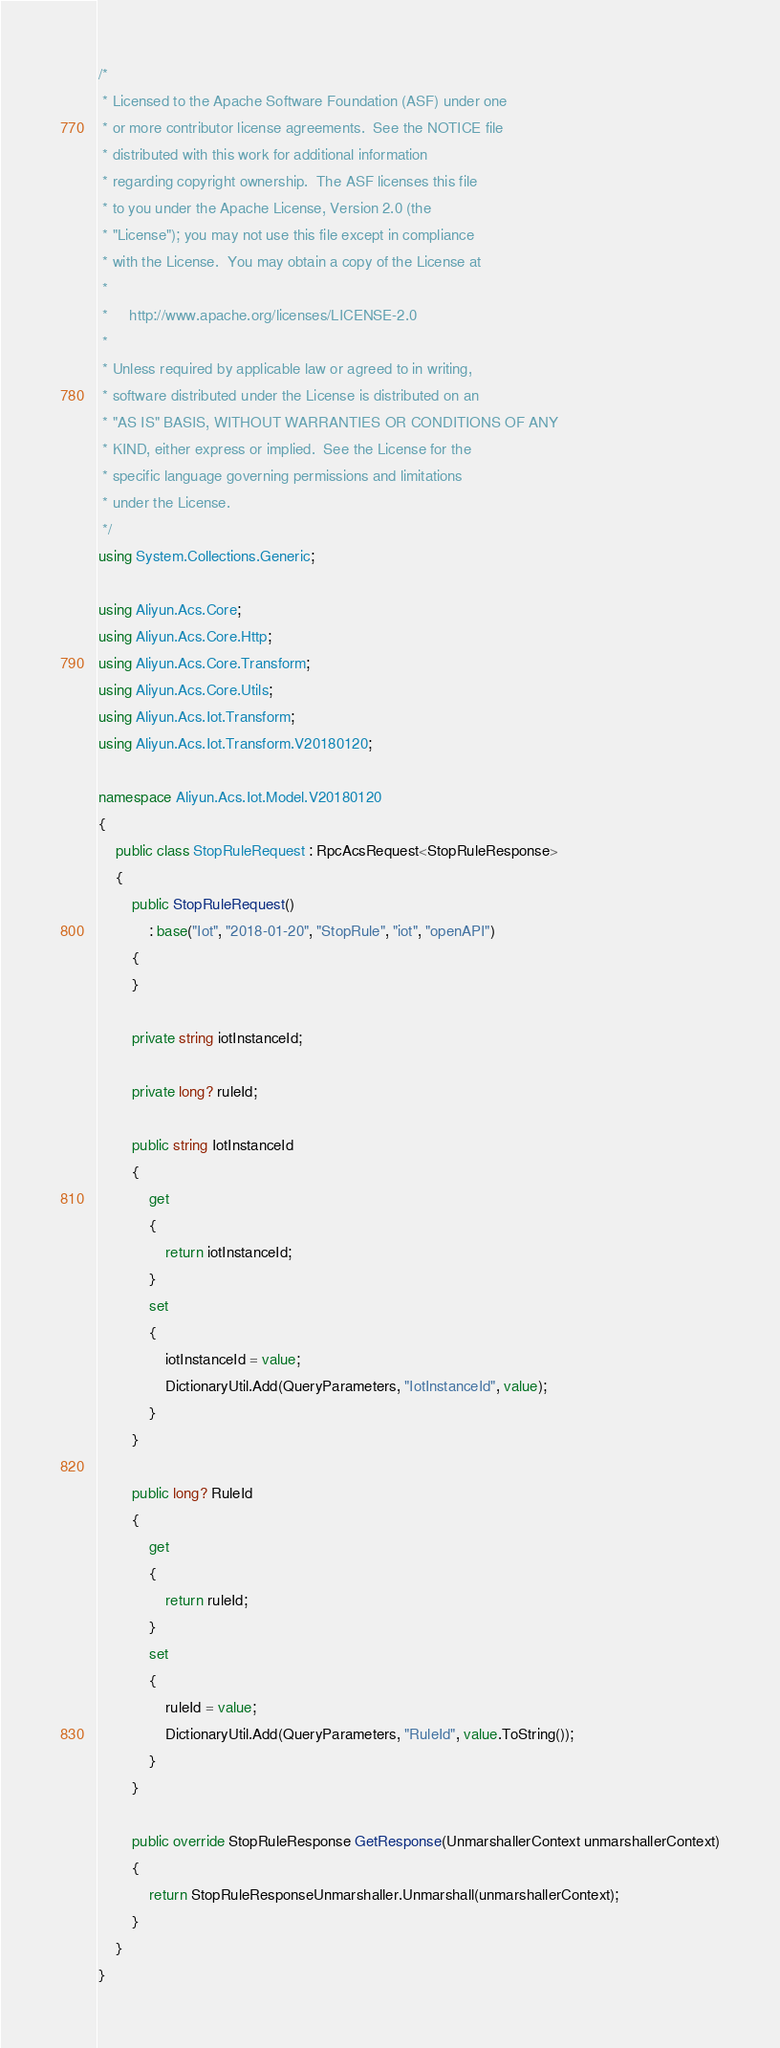Convert code to text. <code><loc_0><loc_0><loc_500><loc_500><_C#_>/*
 * Licensed to the Apache Software Foundation (ASF) under one
 * or more contributor license agreements.  See the NOTICE file
 * distributed with this work for additional information
 * regarding copyright ownership.  The ASF licenses this file
 * to you under the Apache License, Version 2.0 (the
 * "License"); you may not use this file except in compliance
 * with the License.  You may obtain a copy of the License at
 *
 *     http://www.apache.org/licenses/LICENSE-2.0
 *
 * Unless required by applicable law or agreed to in writing,
 * software distributed under the License is distributed on an
 * "AS IS" BASIS, WITHOUT WARRANTIES OR CONDITIONS OF ANY
 * KIND, either express or implied.  See the License for the
 * specific language governing permissions and limitations
 * under the License.
 */
using System.Collections.Generic;

using Aliyun.Acs.Core;
using Aliyun.Acs.Core.Http;
using Aliyun.Acs.Core.Transform;
using Aliyun.Acs.Core.Utils;
using Aliyun.Acs.Iot.Transform;
using Aliyun.Acs.Iot.Transform.V20180120;

namespace Aliyun.Acs.Iot.Model.V20180120
{
    public class StopRuleRequest : RpcAcsRequest<StopRuleResponse>
    {
        public StopRuleRequest()
            : base("Iot", "2018-01-20", "StopRule", "iot", "openAPI")
        {
        }

		private string iotInstanceId;

		private long? ruleId;

		public string IotInstanceId
		{
			get
			{
				return iotInstanceId;
			}
			set	
			{
				iotInstanceId = value;
				DictionaryUtil.Add(QueryParameters, "IotInstanceId", value);
			}
		}

		public long? RuleId
		{
			get
			{
				return ruleId;
			}
			set	
			{
				ruleId = value;
				DictionaryUtil.Add(QueryParameters, "RuleId", value.ToString());
			}
		}

        public override StopRuleResponse GetResponse(UnmarshallerContext unmarshallerContext)
        {
            return StopRuleResponseUnmarshaller.Unmarshall(unmarshallerContext);
        }
    }
}
</code> 